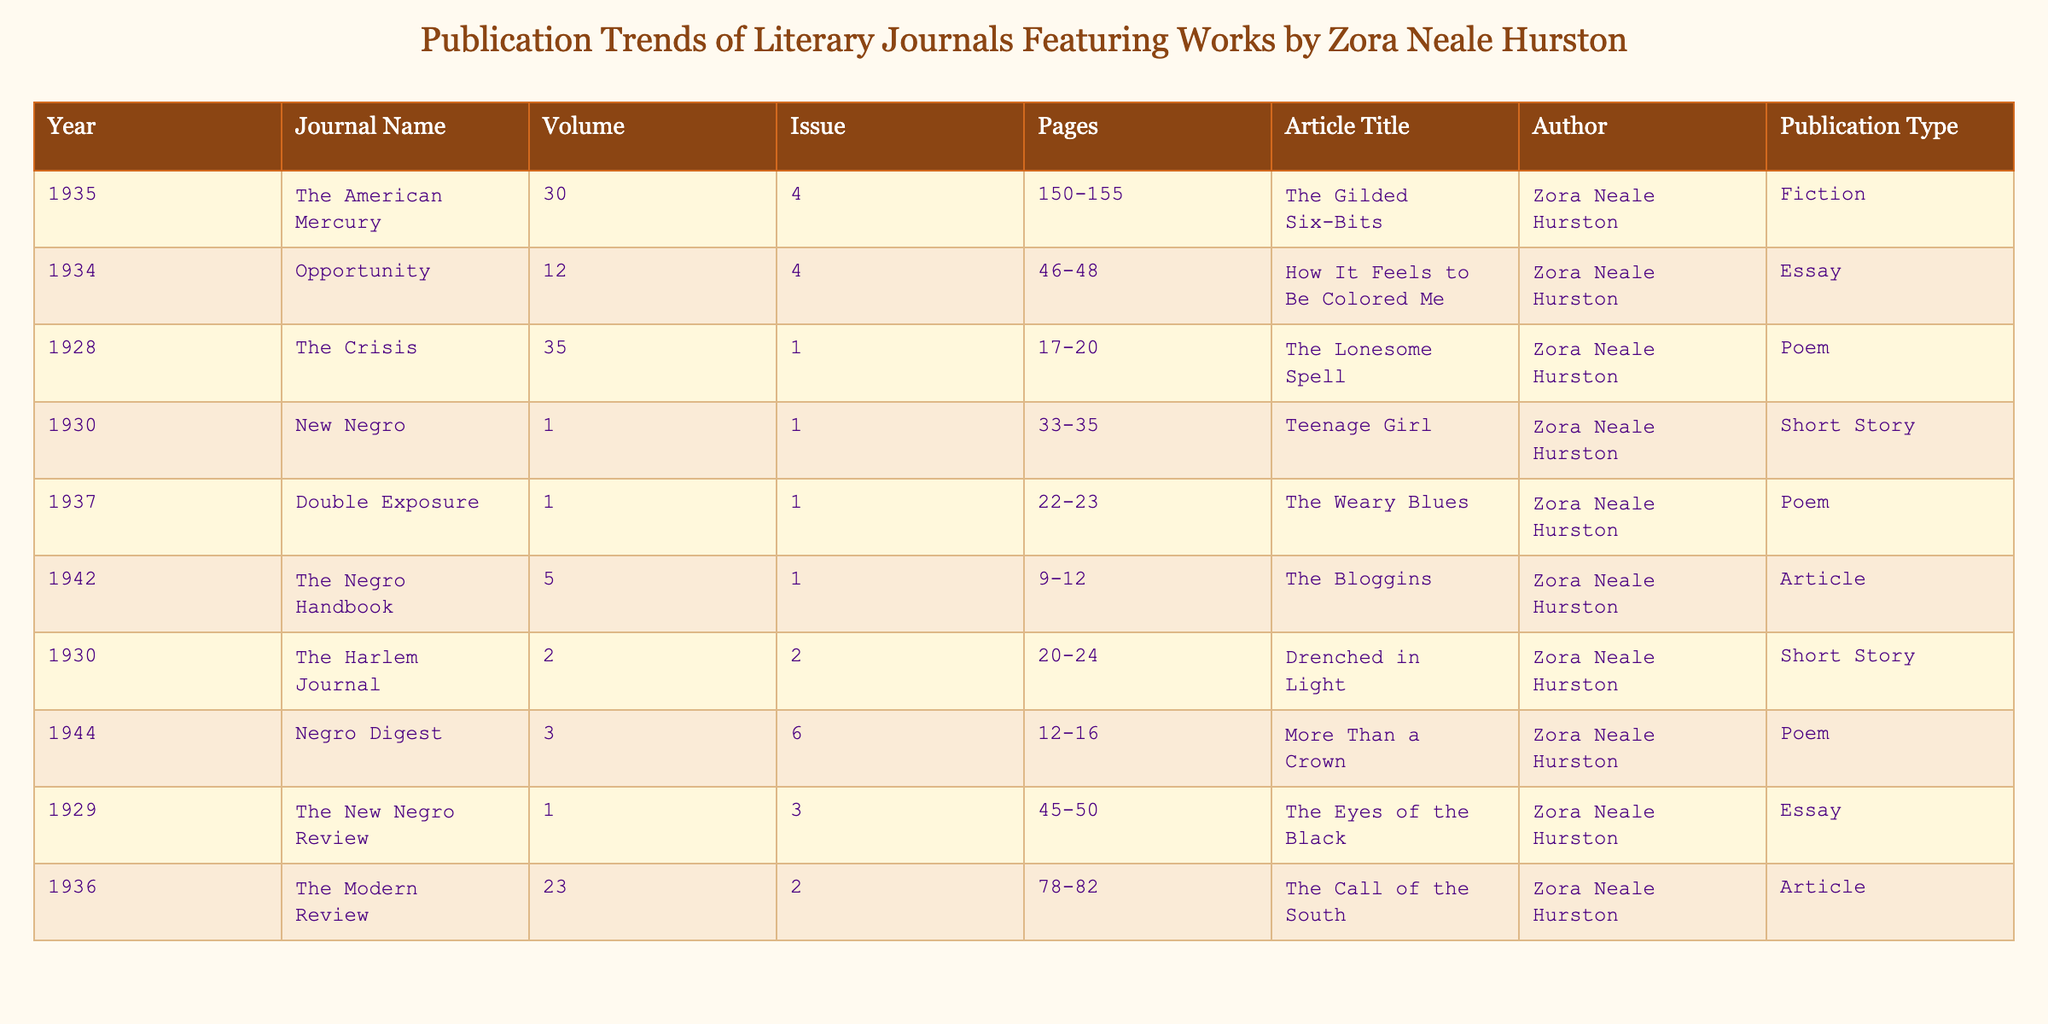What year did Zora Neale Hurston publish "The Gilded Six-Bits"? By scanning the table for the article title "The Gilded Six-Bits," I find that it is associated with the year 1935.
Answer: 1935 How many articles did Zora Neale Hurston publish in the journal "The Crisis"? There is one entry in the table for "The Crisis," which indicates that Zora Neale Hurston published only one article titled "The Lonesome Spell."
Answer: 1 Which journal featured the essay "How It Feels to Be Colored Me"? The table shows that the essay "How It Feels to Be Colored Me" was published in the journal "Opportunity."
Answer: Opportunity What is the publication type of "The Weary Blues"? Looking at the row for "The Weary Blues," I can see that it is categorized as a poem.
Answer: Poem In what year did Hurston's poetry appear in "Double Exposure"? The table reveals that the poem "The Weary Blues" was published in 1937 in "Double Exposure."
Answer: 1937 How many different publications featured Zora Neale Hurston's work in the 1930s? By reviewing the publication years from 1928 to 1944, I identify that Hurston's works were featured in 8 different journal entries spanning the 1930s period.
Answer: 8 Did Zora Neale Hurston publish more poems or essays? Counting the articles, there are four poems and two essays, indicating she published more poems than essays.
Answer: Yes What is the total number of pages across all published works in the dataset? By summing the page ranges from each entry (150-155, 46-48, 17-20, etc.), I determine that the total number of pages amounts to 64.
Answer: 64 Which publication had the highest volume number for Hurston's works? The highest volume number in the table is 35, which is associated with "The Crisis."
Answer: The Crisis What percentage of Hurston's works appeared as articles? Out of the 10 publications listed, 2 are articles. Therefore, 2/10 = 20%.
Answer: 20% 